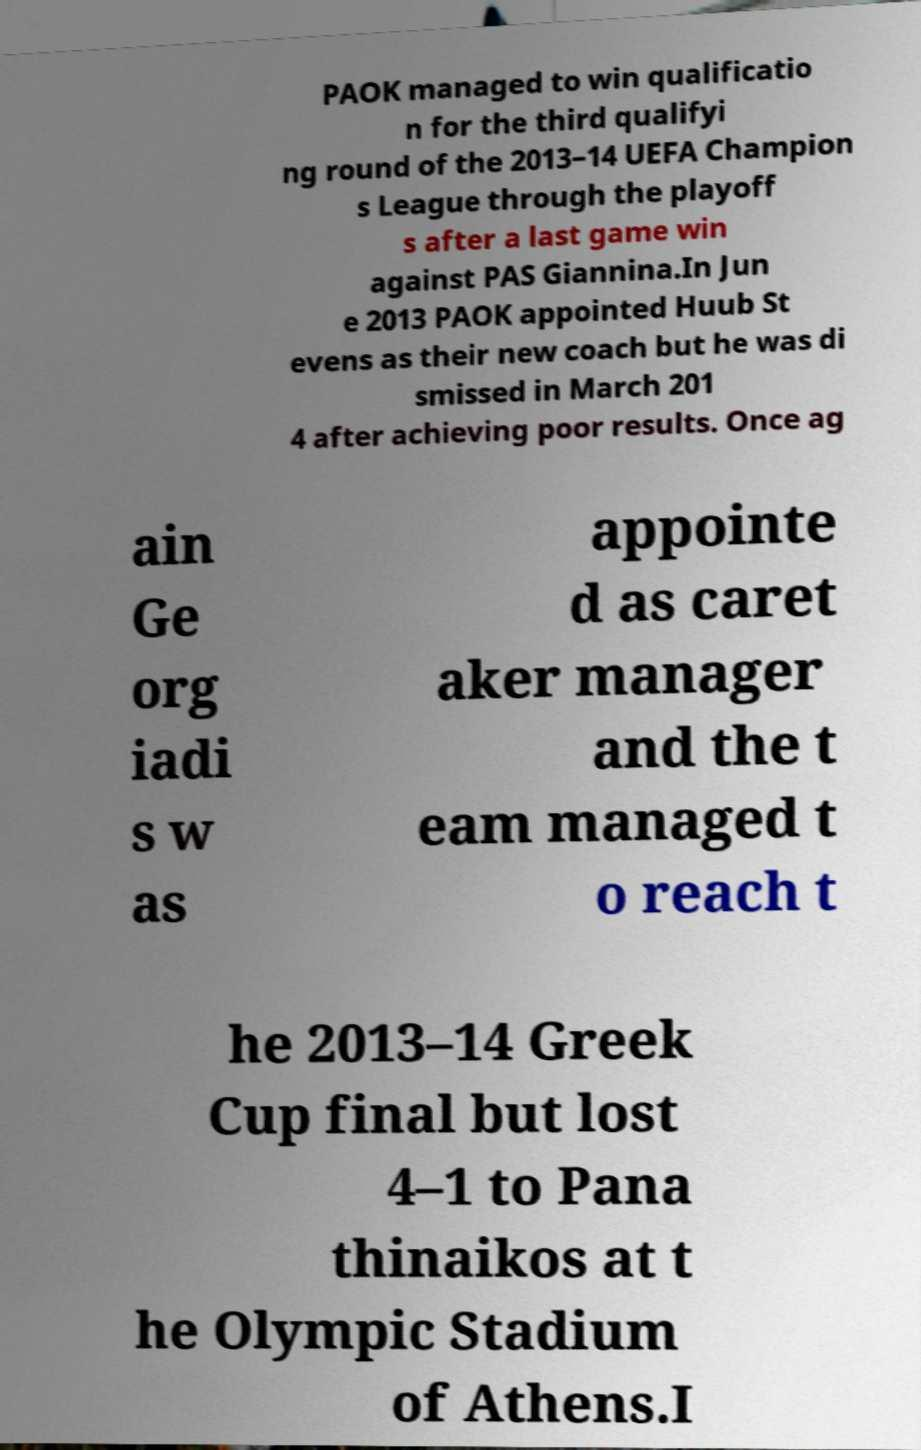Could you assist in decoding the text presented in this image and type it out clearly? PAOK managed to win qualificatio n for the third qualifyi ng round of the 2013–14 UEFA Champion s League through the playoff s after a last game win against PAS Giannina.In Jun e 2013 PAOK appointed Huub St evens as their new coach but he was di smissed in March 201 4 after achieving poor results. Once ag ain Ge org iadi s w as appointe d as caret aker manager and the t eam managed t o reach t he 2013–14 Greek Cup final but lost 4–1 to Pana thinaikos at t he Olympic Stadium of Athens.I 